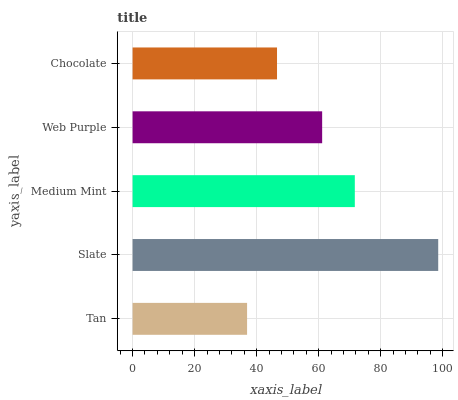Is Tan the minimum?
Answer yes or no. Yes. Is Slate the maximum?
Answer yes or no. Yes. Is Medium Mint the minimum?
Answer yes or no. No. Is Medium Mint the maximum?
Answer yes or no. No. Is Slate greater than Medium Mint?
Answer yes or no. Yes. Is Medium Mint less than Slate?
Answer yes or no. Yes. Is Medium Mint greater than Slate?
Answer yes or no. No. Is Slate less than Medium Mint?
Answer yes or no. No. Is Web Purple the high median?
Answer yes or no. Yes. Is Web Purple the low median?
Answer yes or no. Yes. Is Slate the high median?
Answer yes or no. No. Is Medium Mint the low median?
Answer yes or no. No. 